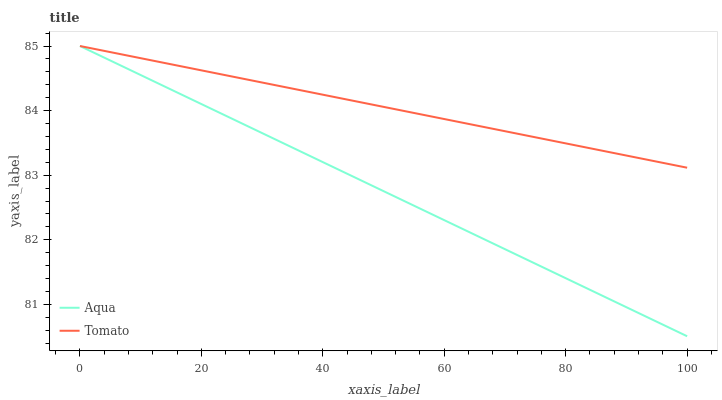Does Aqua have the minimum area under the curve?
Answer yes or no. Yes. Does Tomato have the maximum area under the curve?
Answer yes or no. Yes. Does Aqua have the maximum area under the curve?
Answer yes or no. No. Is Tomato the smoothest?
Answer yes or no. Yes. Is Aqua the roughest?
Answer yes or no. Yes. Is Aqua the smoothest?
Answer yes or no. No. Does Aqua have the lowest value?
Answer yes or no. Yes. Does Aqua have the highest value?
Answer yes or no. Yes. Does Aqua intersect Tomato?
Answer yes or no. Yes. Is Aqua less than Tomato?
Answer yes or no. No. Is Aqua greater than Tomato?
Answer yes or no. No. 